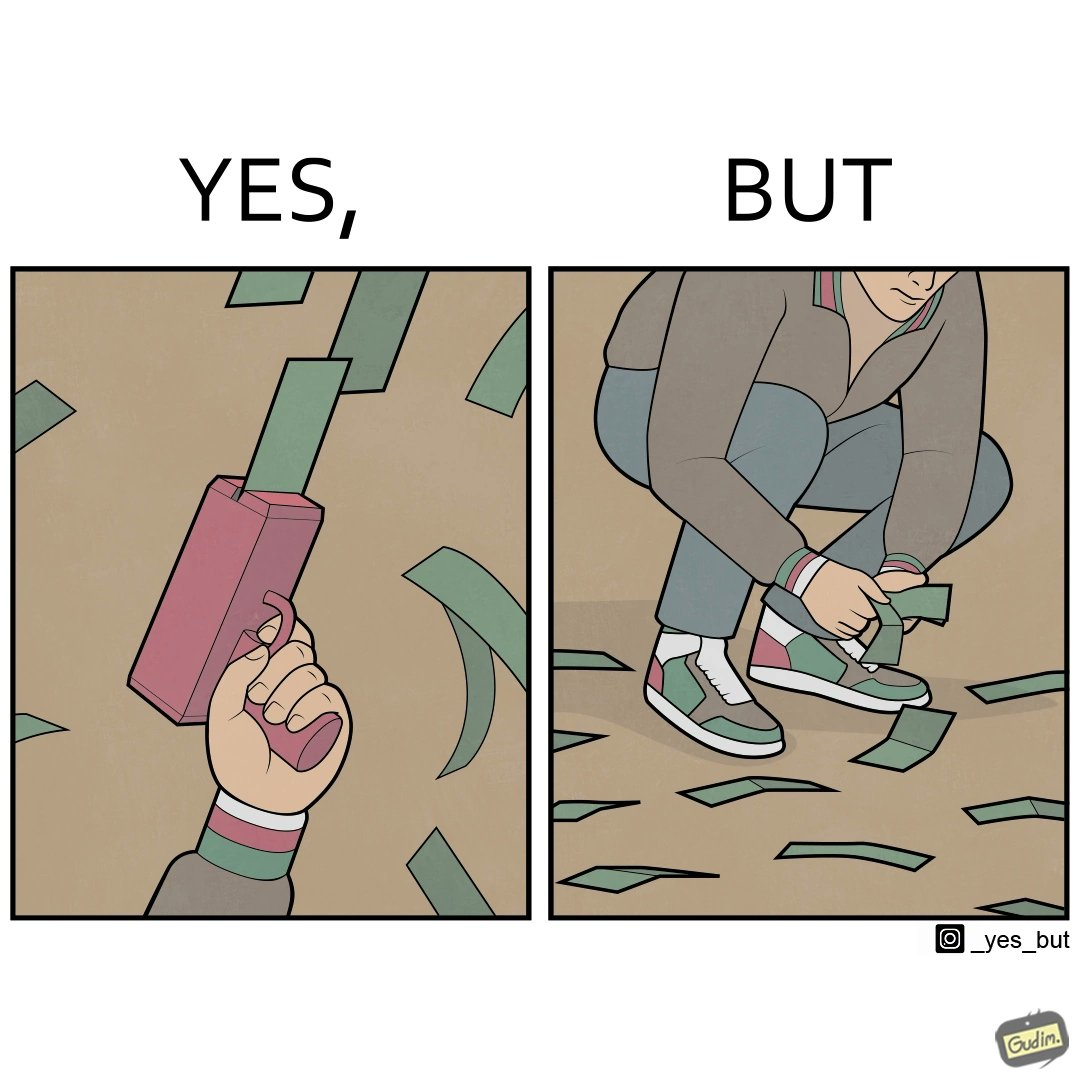Provide a description of this image. The image is satirical because the man that is shooting money in the air causing a rain of money bills is the same person who is crouching down to collect the fallen dollar bills from the ground which makes the act of shooting bills in the air not so fun. 